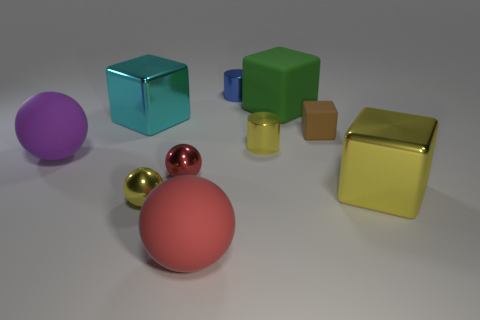How many objects are either tiny yellow metallic things on the right side of the small red metal ball or green rubber blocks?
Keep it short and to the point. 2. Are there any red balls?
Make the answer very short. Yes. There is a big sphere that is on the left side of the large red thing; what material is it?
Your response must be concise. Rubber. What number of large objects are brown matte things or red cubes?
Offer a very short reply. 0. The small rubber thing is what color?
Provide a succinct answer. Brown. There is a big metal cube left of the big green rubber block; are there any yellow shiny spheres to the left of it?
Offer a terse response. No. Are there fewer tiny cylinders that are to the left of the red metal object than tiny metal things?
Ensure brevity in your answer.  Yes. Is the big purple thing that is in front of the small brown matte object made of the same material as the large green block?
Provide a succinct answer. Yes. The other tiny cylinder that is made of the same material as the small yellow cylinder is what color?
Your answer should be compact. Blue. Are there fewer large cyan metal blocks to the right of the big red thing than brown matte cubes in front of the yellow metallic cylinder?
Provide a succinct answer. No. 